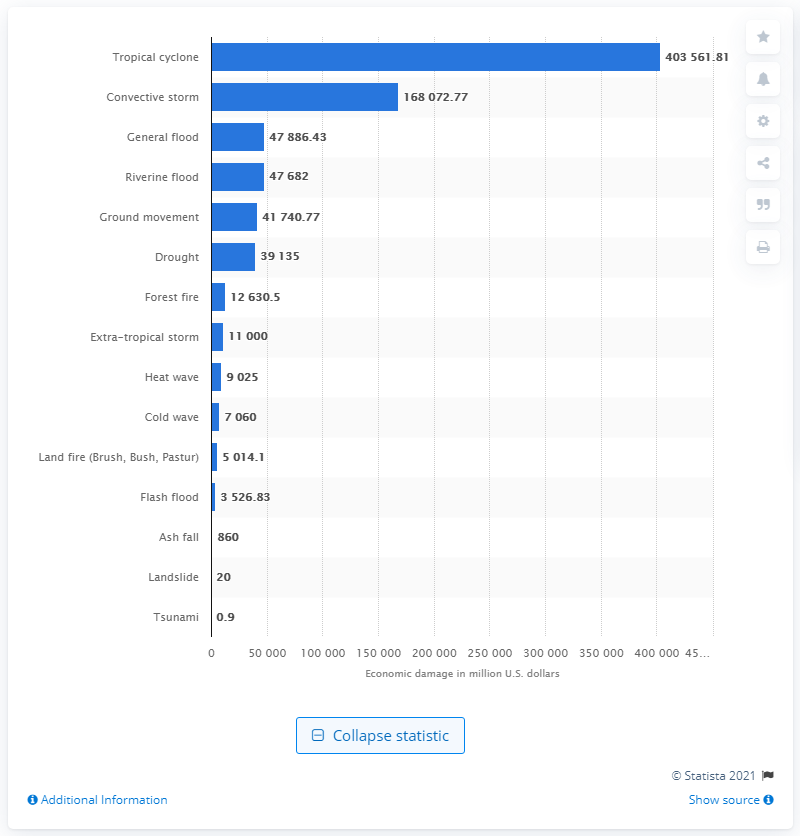Give some essential details in this illustration. The tropical cyclone has caused a significant amount of damage in the United States since 1900, with a total of 403,561.81 units of damage recorded. 